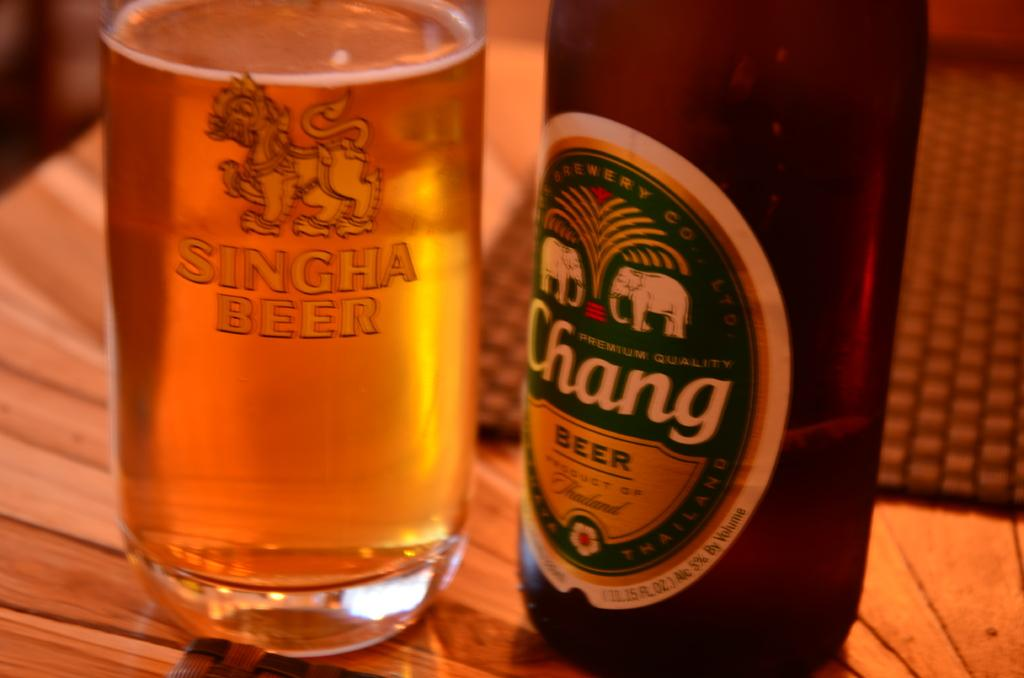What objects are on the table in the image? There are bottles on the table. What is covering the table in the image? There is a mat on the table. What is the profit margin of the bottles in the image? There is no information about profit margins in the image, as it only shows bottles on a table. 